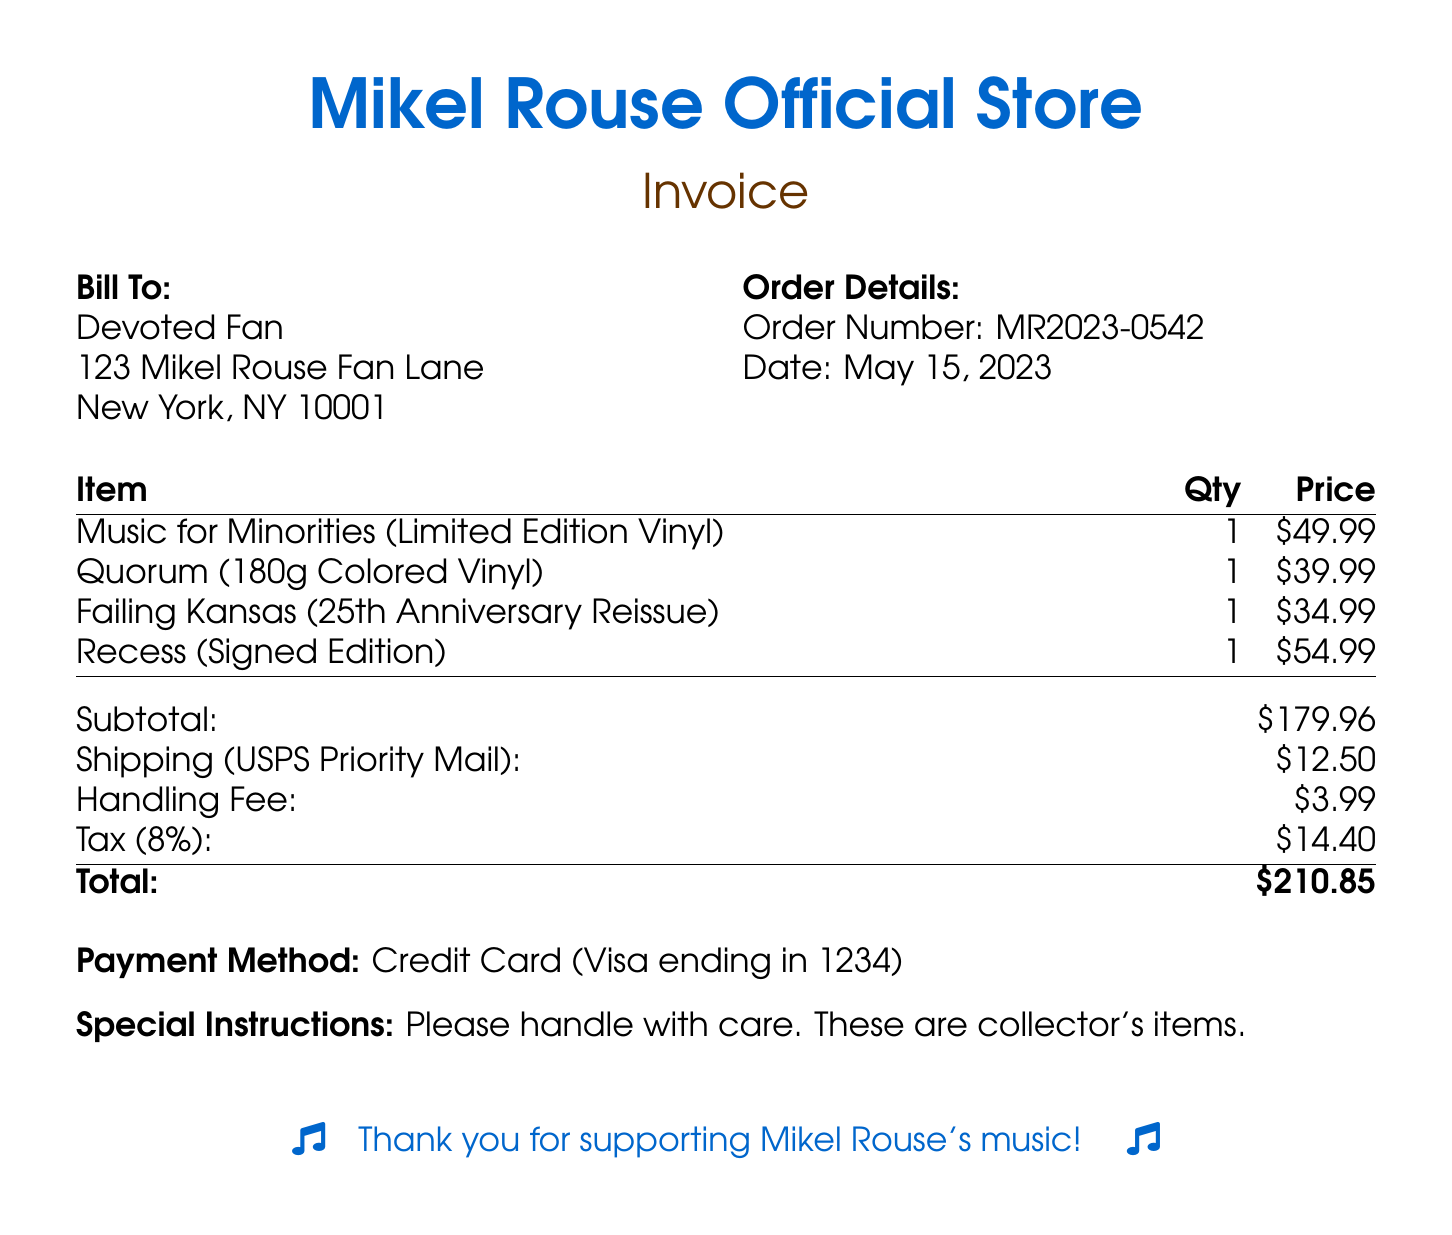What is the order number? The order number is listed under the order details section of the document.
Answer: MR2023-0542 What is the subtotal of the order? The subtotal is calculated from the prices of the items before tax and additional charges.
Answer: $179.96 How many copies of "Music for Minorities" were ordered? The quantity ordered for each item is specified in the itemized list.
Answer: 1 What is the shipping cost? The shipping cost is stated in the charges section of the document.
Answer: $12.50 What is the date of the order? The date is provided in the order details section of the document.
Answer: May 15, 2023 What is the handling fee? The handling fee is listed among the additional charges in the document.
Answer: $3.99 What percentage is the tax applied to the subtotal? The tax percentage is noted in the charges section of the document.
Answer: 8% What is the total amount due? The total amount is the final amount after adding all charges, including tax, to the subtotal.
Answer: $210.85 What is the payment method used? The payment method is mentioned at the bottom of the document.
Answer: Credit Card (Visa ending in 1234) 